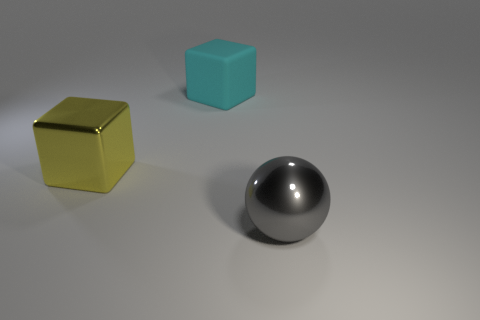Subtract all cyan cubes. How many cubes are left? 1 Subtract all cubes. How many objects are left? 1 Subtract all large matte blocks. Subtract all matte things. How many objects are left? 1 Add 2 large cubes. How many large cubes are left? 4 Add 1 cyan blocks. How many cyan blocks exist? 2 Add 2 blue shiny balls. How many objects exist? 5 Subtract 0 green blocks. How many objects are left? 3 Subtract all green blocks. Subtract all yellow cylinders. How many blocks are left? 2 Subtract all blue cylinders. How many gray cubes are left? 0 